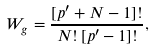Convert formula to latex. <formula><loc_0><loc_0><loc_500><loc_500>W _ { g } = \frac { [ p ^ { \prime } + N - 1 ] ! } { N ! \, [ p ^ { \prime } - 1 ] ! } ,</formula> 